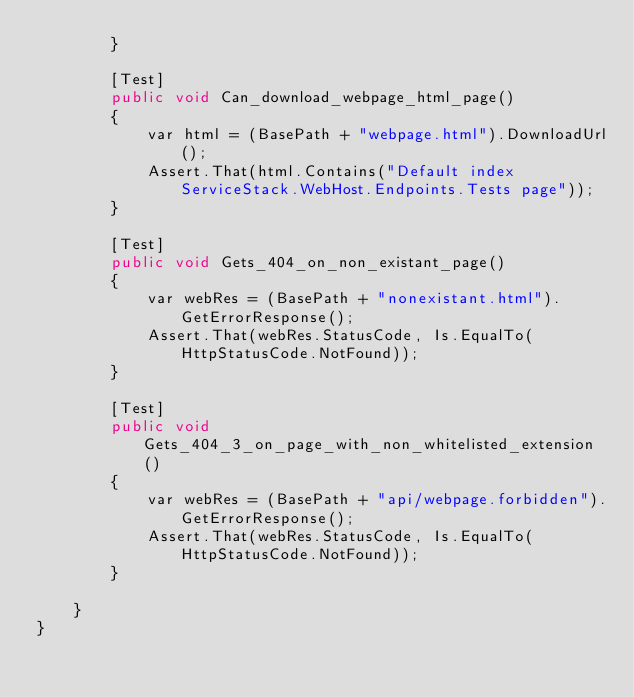Convert code to text. <code><loc_0><loc_0><loc_500><loc_500><_C#_>		}

		[Test]
		public void Can_download_webpage_html_page()
		{
			var html = (BasePath + "webpage.html").DownloadUrl();
			Assert.That(html.Contains("Default index ServiceStack.WebHost.Endpoints.Tests page"));
		}

		[Test]
		public void Gets_404_on_non_existant_page()
		{
			var webRes = (BasePath + "nonexistant.html").GetErrorResponse();
			Assert.That(webRes.StatusCode, Is.EqualTo(HttpStatusCode.NotFound));
		}

		[Test]
		public void Gets_404_3_on_page_with_non_whitelisted_extension()
		{
			var webRes = (BasePath + "api/webpage.forbidden").GetErrorResponse();
			Assert.That(webRes.StatusCode, Is.EqualTo(HttpStatusCode.NotFound));
		}
		 
	}
}</code> 